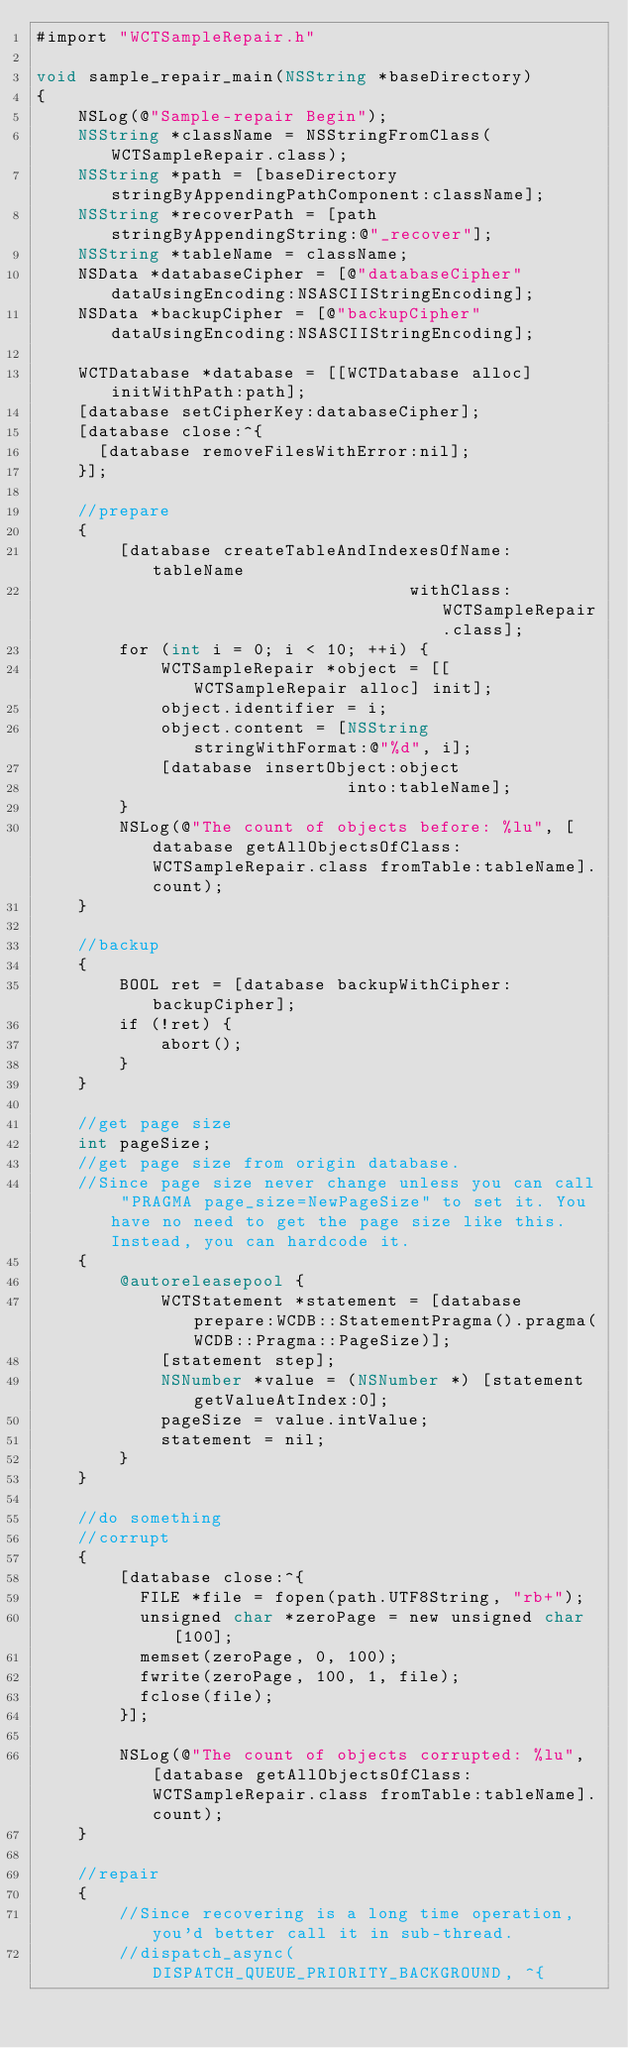<code> <loc_0><loc_0><loc_500><loc_500><_ObjectiveC_>#import "WCTSampleRepair.h"

void sample_repair_main(NSString *baseDirectory)
{
    NSLog(@"Sample-repair Begin");
    NSString *className = NSStringFromClass(WCTSampleRepair.class);
    NSString *path = [baseDirectory stringByAppendingPathComponent:className];
    NSString *recoverPath = [path stringByAppendingString:@"_recover"];
    NSString *tableName = className;
    NSData *databaseCipher = [@"databaseCipher" dataUsingEncoding:NSASCIIStringEncoding];
    NSData *backupCipher = [@"backupCipher" dataUsingEncoding:NSASCIIStringEncoding];

    WCTDatabase *database = [[WCTDatabase alloc] initWithPath:path];
    [database setCipherKey:databaseCipher];
    [database close:^{
      [database removeFilesWithError:nil];
    }];

    //prepare
    {
        [database createTableAndIndexesOfName:tableName
                                    withClass:WCTSampleRepair.class];
        for (int i = 0; i < 10; ++i) {
            WCTSampleRepair *object = [[WCTSampleRepair alloc] init];
            object.identifier = i;
            object.content = [NSString stringWithFormat:@"%d", i];
            [database insertObject:object
                              into:tableName];
        }
        NSLog(@"The count of objects before: %lu", [database getAllObjectsOfClass:WCTSampleRepair.class fromTable:tableName].count);
    }

    //backup
    {
        BOOL ret = [database backupWithCipher:backupCipher];
        if (!ret) {
            abort();
        }
    }

    //get page size
    int pageSize;
    //get page size from origin database.
    //Since page size never change unless you can call "PRAGMA page_size=NewPageSize" to set it. You have no need to get the page size like this. Instead, you can hardcode it.
    {
        @autoreleasepool {
            WCTStatement *statement = [database prepare:WCDB::StatementPragma().pragma(WCDB::Pragma::PageSize)];
            [statement step];
            NSNumber *value = (NSNumber *) [statement getValueAtIndex:0];
            pageSize = value.intValue;
            statement = nil;
        }
    }

    //do something
    //corrupt
    {
        [database close:^{
          FILE *file = fopen(path.UTF8String, "rb+");
          unsigned char *zeroPage = new unsigned char[100];
          memset(zeroPage, 0, 100);
          fwrite(zeroPage, 100, 1, file);
          fclose(file);
        }];

        NSLog(@"The count of objects corrupted: %lu", [database getAllObjectsOfClass:WCTSampleRepair.class fromTable:tableName].count);
    }

    //repair
    {
        //Since recovering is a long time operation, you'd better call it in sub-thread.
        //dispatch_async(DISPATCH_QUEUE_PRIORITY_BACKGROUND, ^{</code> 